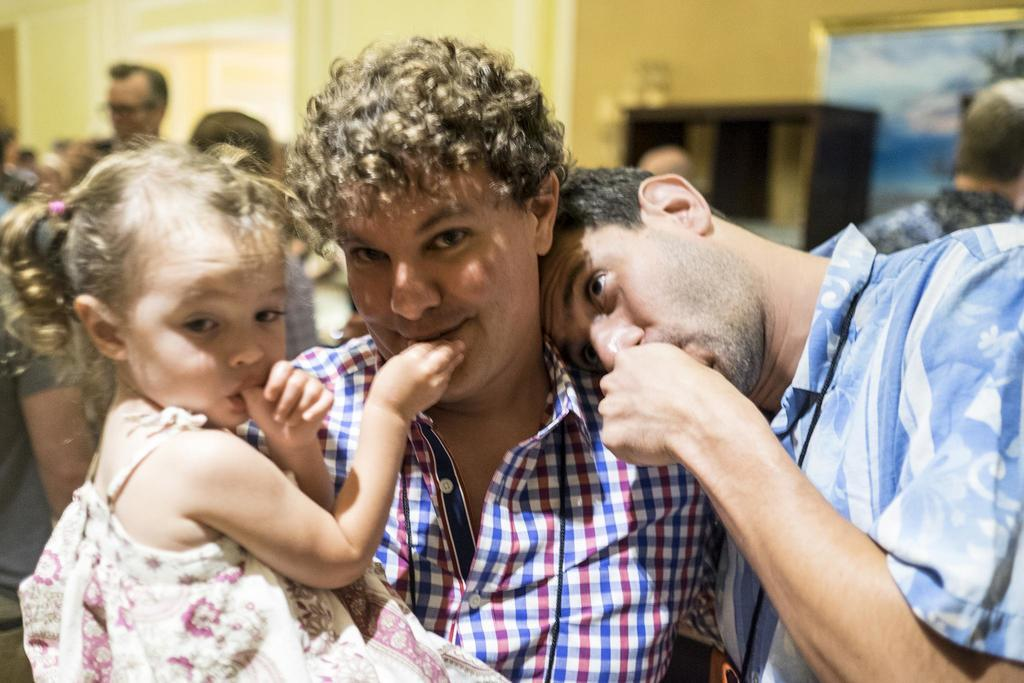What is the main action taking place in the image? There is a man holding a child in the image. Who else is present in the image? There is another man near the man near the first man. What can be seen in the background of the image? There are multiple people in the background of the image. How would you describe the background of the image? The background appears blurred. How many bats are flying in the image? There are no bats visible in the image. What type of sorting activity is taking place in the image? There is no sorting activity present in the image. 